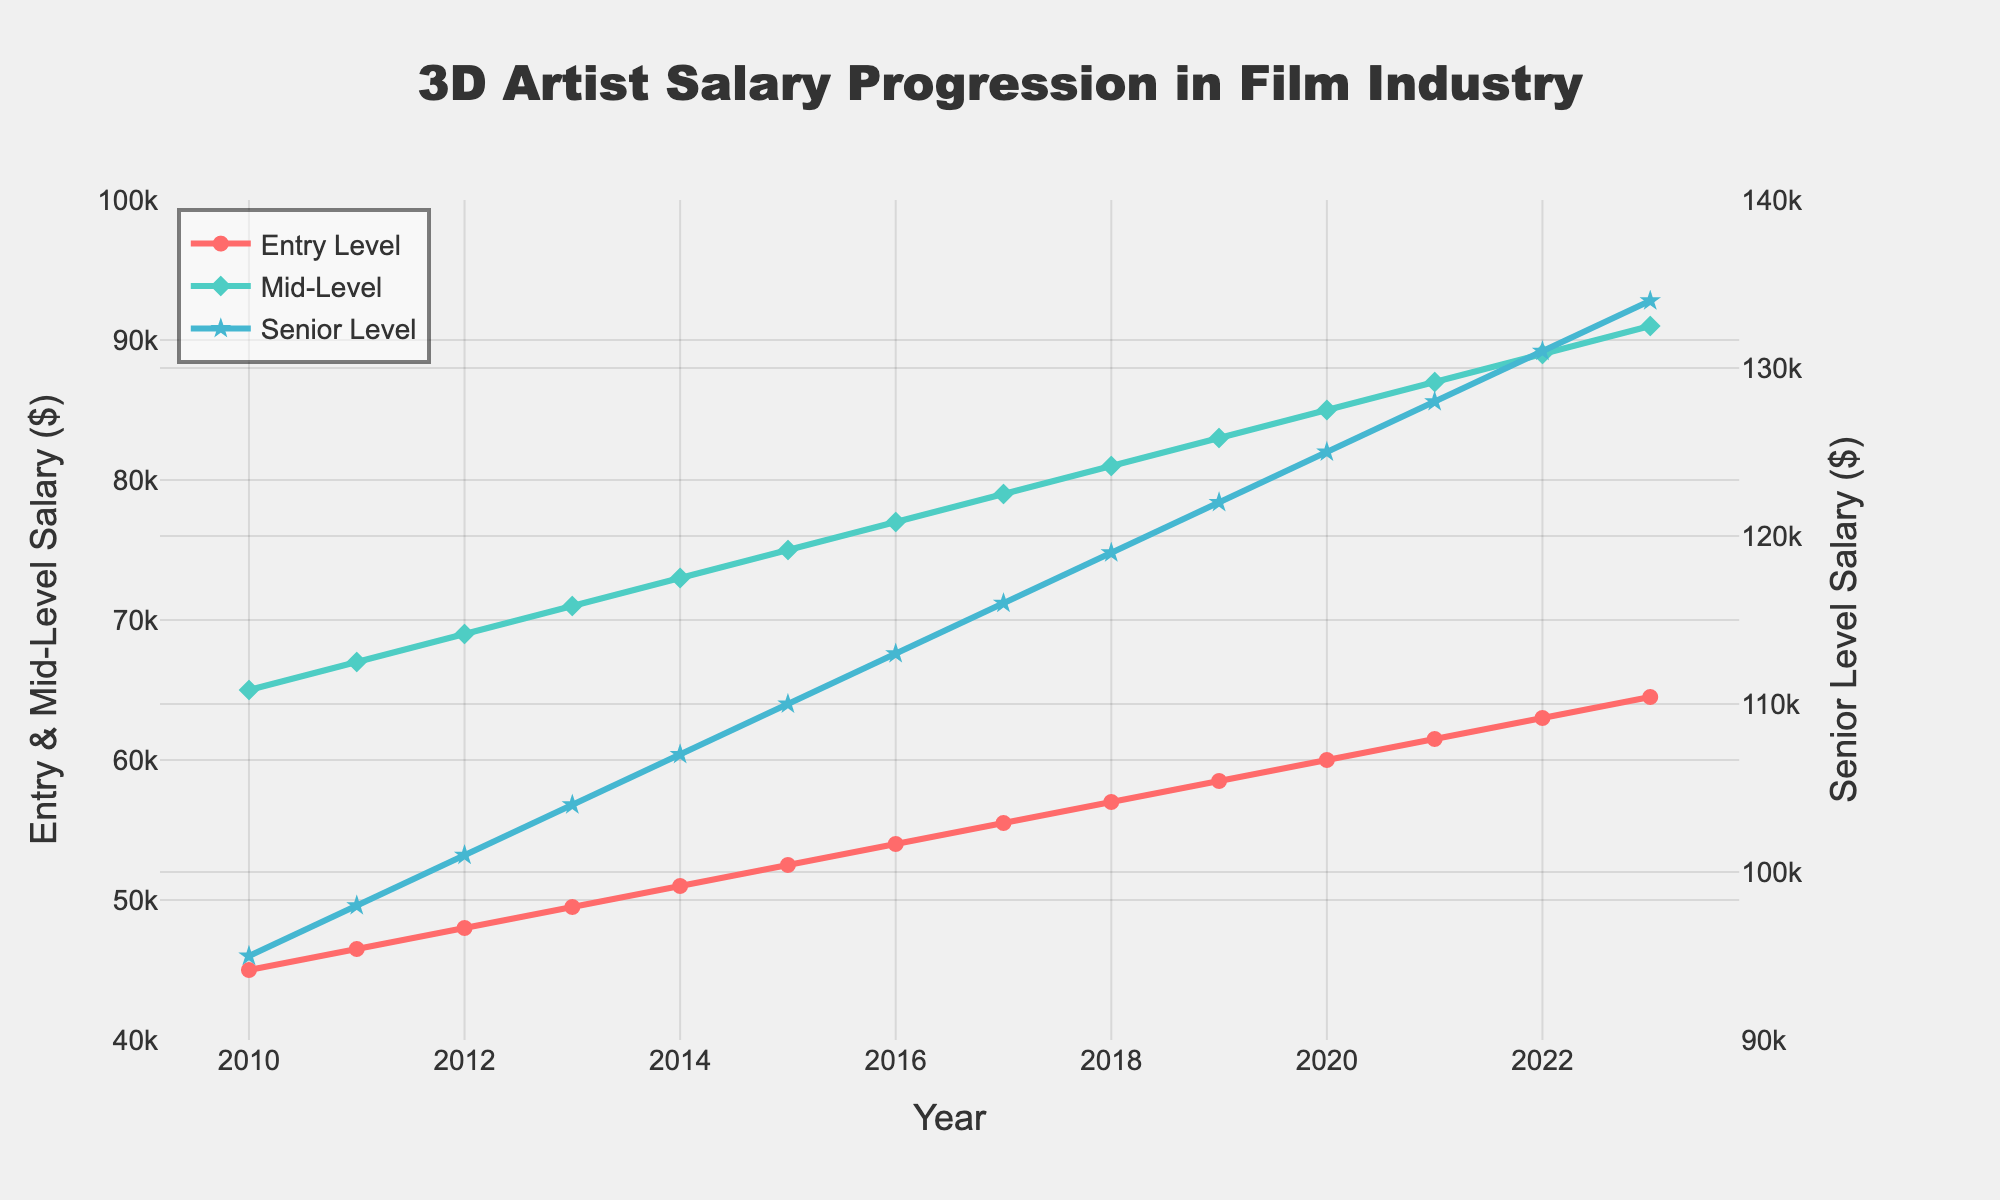What's the difference between the Senior Level Salary and the Entry Level Salary in 2023? In 2023, the Senior Level Salary is $134,000 and the Entry Level Salary is $64,500. The difference is calculated by subtracting the Entry Level Salary from the Senior Level Salary: $134,000 - $64,500 = $69,500.
Answer: $69,500 How much did the Mid-Level Salary increase from 2010 to 2020? In 2010, the Mid-Level Salary was $65,000, and in 2020, it was $85,000. The increase is calculated by subtracting the 2010 salary from the 2020 salary: $85,000 - $65,000 = $20,000.
Answer: $20,000 Which salary category shows the highest growth rate from 2010 to 2023? To determine the highest growth rate, we look at the increase in each salary category from 2010 to 2023:
- Entry Level increases from $45,000 to $64,500, an increase of $19,500.
- Mid-Level increases from $65,000 to $91,000, an increase of $26,000.
- Senior Level increases from $95,000 to $134,000, an increase of $39,000.
The Senior Level Salary shows the highest growth rate of $39,000.
Answer: Senior Level Salary What is the overall average salary for Entry Level, Mid-Level, and Senior Level across all years shown? To find the overall average, we sum the salaries for each category across the years and then divide by the number of years (14):
- Entry Level: (45000 + 46500 + 48000 + ... + 64500) = 814500.
- Mid-Level: (65000 + 67000 + 69000 + ... + 91000) = 1113000.
- Senior Level: (95000 + 98000 + 101000 + ... + 134000) = 1605000.
Then calculate the average for each:
- Entry Level: 814500 / 14 = 58,179 approx.
- Mid-Level: 1113000 / 14 = 79,500.
- Senior Level: 1605000 / 14 = 114,643 approx.
Next, take the average of these averages: (58,179 + 79,500 + 114,643)/3 = 84,107 approx.
Answer: $84,107 approx What year did the Entry Level Salary cross the $50,000 mark? By examining the dataset, the Entry Level Salary first reaches $51,000 in 2014.
Answer: 2014 Is the difference between Entry Level and Senior Level Salary consistent over the years or does it vary? The difference between Entry Level and Senior Level Salary is calculated for each year and compared:
- 2010: $95,000 - $45,000 = $50,000
- 2011: $98,000 - $46,500 = $51,500
- 2012: $101,000 - $48,000 = $53,000
- ...
- 2023: $134,000 - $64,500 = $69,500
The difference gradually increases, indicating it varies and is not consistent.
Answer: It varies During which period was the salary growth of Entry Level and Mid-Level artists in sync? To check this, we examine where the increase in salaries for both Entry Level and Mid-Level match:
- 2010 to 2011: Entry Level increased by $1,500; Mid-Level by $2,000.
- 2011 to 2012: Entry Level increased by $1,500; Mid-Level by $2,000.
- 2012 to 2013: Entry Level increased by $1,500; Mid-Level by $2,000.
- Consistently, from 2010 to 2013, the increments are proportionally in sync.
Answer: 2010 to 2013 